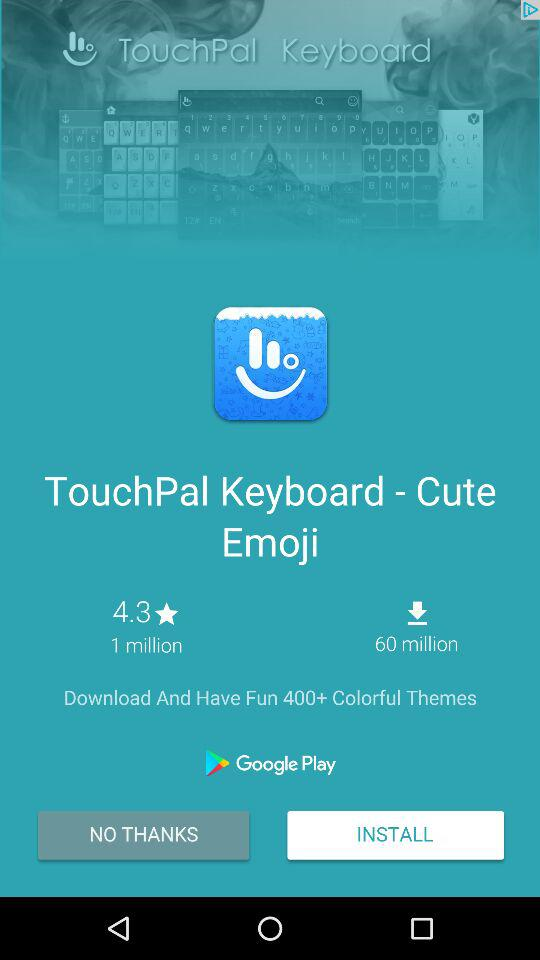How many more downloads does the app have than reviews?
Answer the question using a single word or phrase. 59 million 